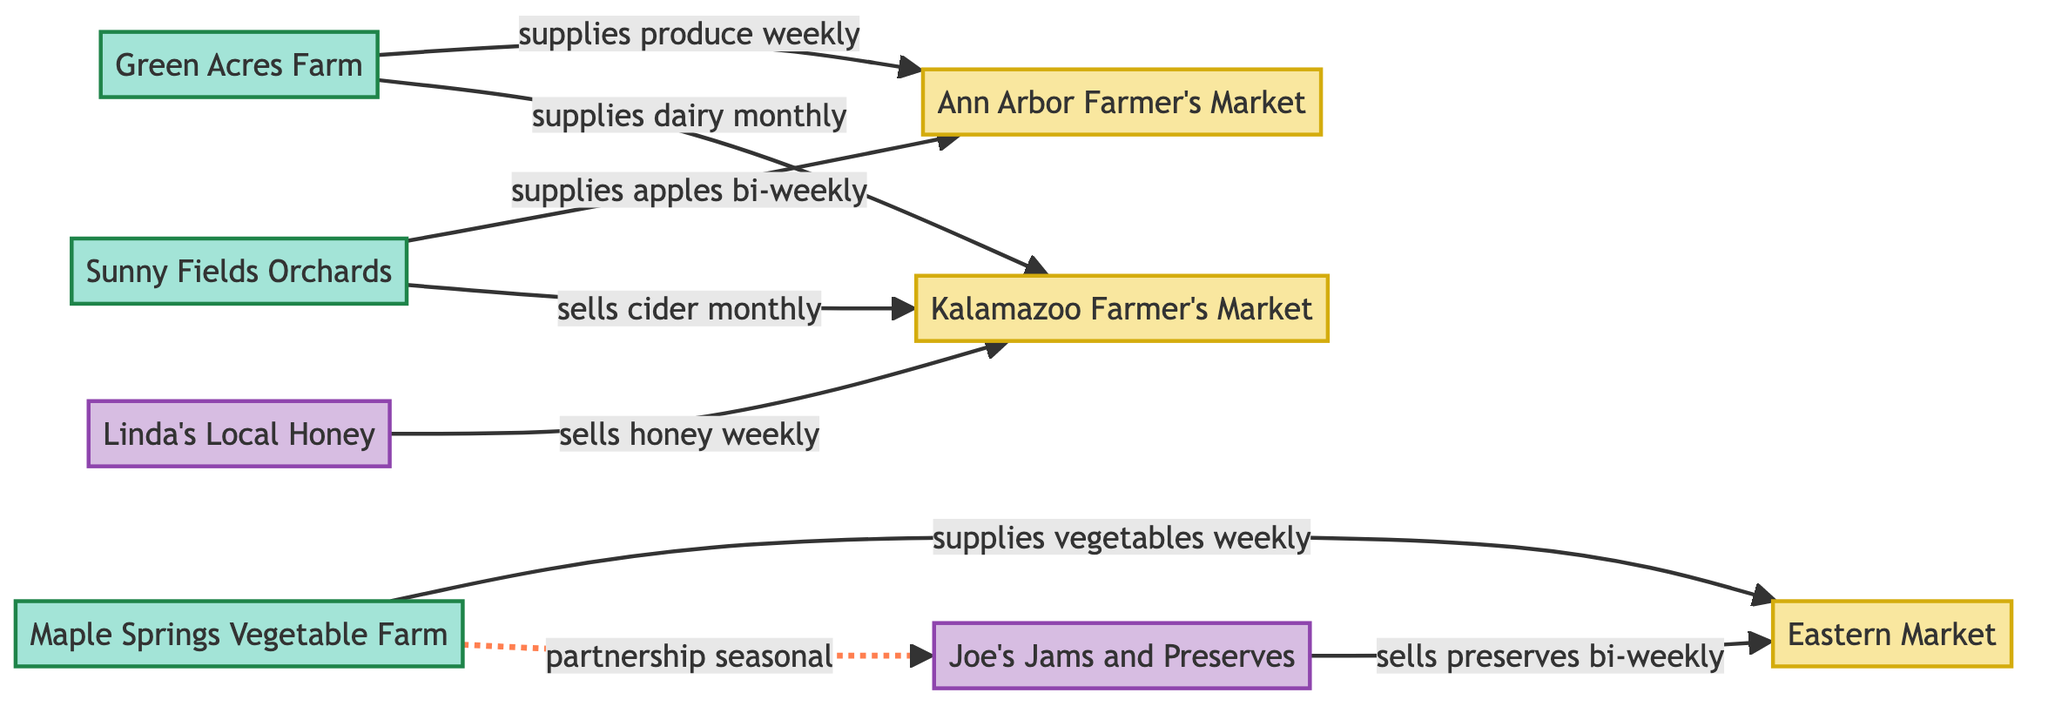What is the frequency at which Green Acres Farm supplies produce to the Ann Arbor Farmer's Market? According to the edge representing the relationship between Green Acres Farm and Ann Arbor Farmer's Market, the label "supplies produce" is followed by the frequency "weekly".
Answer: weekly How many total farms are shown in the diagram? By counting the nodes that are labeled as "Farm", we identify three farms: Green Acres Farm, Sunny Fields Orchards, and Maple Springs Vegetable Farm.
Answer: 3 Which vendor sells honey? The vendor represented by the node labeled "Linda's Local Honey" sells honey, as indicated by the edge connecting it to the Kalamazoo Farmer's Market with the label "sells honey".
Answer: Linda's Local Honey What type of produce does Sunny Fields Orchards supply to Ann Arbor Farmer's Market? The edge connecting Sunny Fields Orchards to Ann Arbor Farmer's Market shows that it "supplies apples".
Answer: apples What is the relationship frequency between Maple Springs Vegetable Farm and Eastern Market? The edge from Maple Springs Vegetable Farm to Eastern Market shows that it "supplies vegetables" with a frequency of "weekly".
Answer: weekly Which vendor has a seasonal partnership with Maple Springs Vegetable Farm? Looking at the edge that indicates the relationship between Maple Springs Vegetable Farm and Joe's Jams and Preserves, it is labeled "partnership seasonal".
Answer: Joe's Jams and Preserves How often does Sunny Fields Orchards sell cider at Kalamazoo Farmer's Market? The edge from Sunny Fields Orchards to Kalamazoo Farmer's Market states it "sells cider" with a frequency of "monthly".
Answer: monthly Which market does Maple Springs Vegetable Farm supply weekly? The edge connecting Maple Springs Vegetable Farm indicates it supplies vegetables to Eastern Market on a weekly basis.
Answer: Eastern Market 